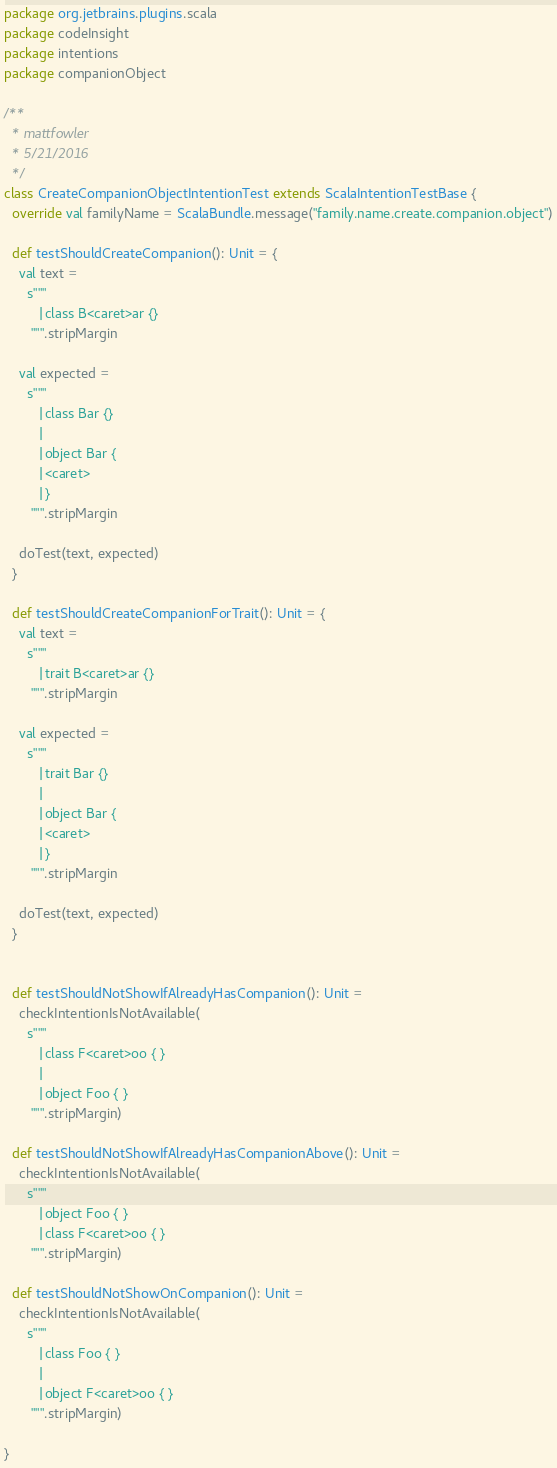<code> <loc_0><loc_0><loc_500><loc_500><_Scala_>package org.jetbrains.plugins.scala
package codeInsight
package intentions
package companionObject

/**
  * mattfowler
  * 5/21/2016
  */
class CreateCompanionObjectIntentionTest extends ScalaIntentionTestBase {
  override val familyName = ScalaBundle.message("family.name.create.companion.object")

  def testShouldCreateCompanion(): Unit = {
    val text =
      s"""
         |class B<caret>ar {}
       """.stripMargin

    val expected =
      s"""
         |class Bar {}
         |
         |object Bar {
         |<caret>
         |}
       """.stripMargin

    doTest(text, expected)
  }

  def testShouldCreateCompanionForTrait(): Unit = {
    val text =
      s"""
         |trait B<caret>ar {}
       """.stripMargin

    val expected =
      s"""
         |trait Bar {}
         |
         |object Bar {
         |<caret>
         |}
       """.stripMargin

    doTest(text, expected)
  }


  def testShouldNotShowIfAlreadyHasCompanion(): Unit =
    checkIntentionIsNotAvailable(
      s"""
         |class F<caret>oo { }
         |
         |object Foo { }
       """.stripMargin)

  def testShouldNotShowIfAlreadyHasCompanionAbove(): Unit =
    checkIntentionIsNotAvailable(
      s"""
         |object Foo { }
         |class F<caret>oo { }
       """.stripMargin)

  def testShouldNotShowOnCompanion(): Unit =
    checkIntentionIsNotAvailable(
      s"""
         |class Foo { }
         |
         |object F<caret>oo { }
       """.stripMargin)

}
</code> 